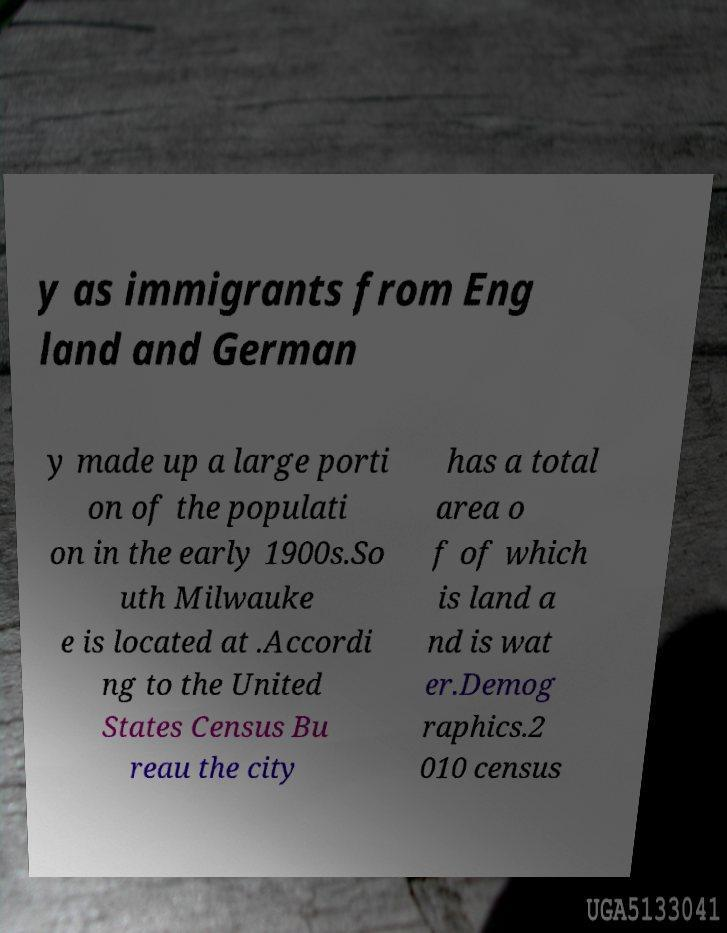There's text embedded in this image that I need extracted. Can you transcribe it verbatim? y as immigrants from Eng land and German y made up a large porti on of the populati on in the early 1900s.So uth Milwauke e is located at .Accordi ng to the United States Census Bu reau the city has a total area o f of which is land a nd is wat er.Demog raphics.2 010 census 